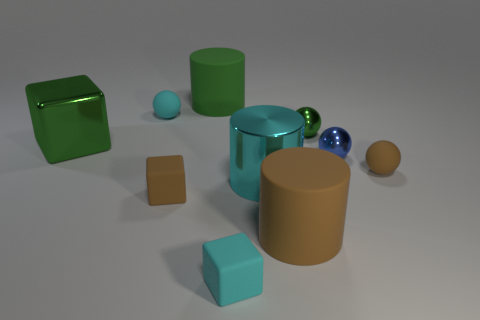Subtract 1 balls. How many balls are left? 3 Subtract all balls. How many objects are left? 6 Subtract 1 green cubes. How many objects are left? 9 Subtract all brown rubber cylinders. Subtract all brown spheres. How many objects are left? 8 Add 7 small green things. How many small green things are left? 8 Add 3 large red matte spheres. How many large red matte spheres exist? 3 